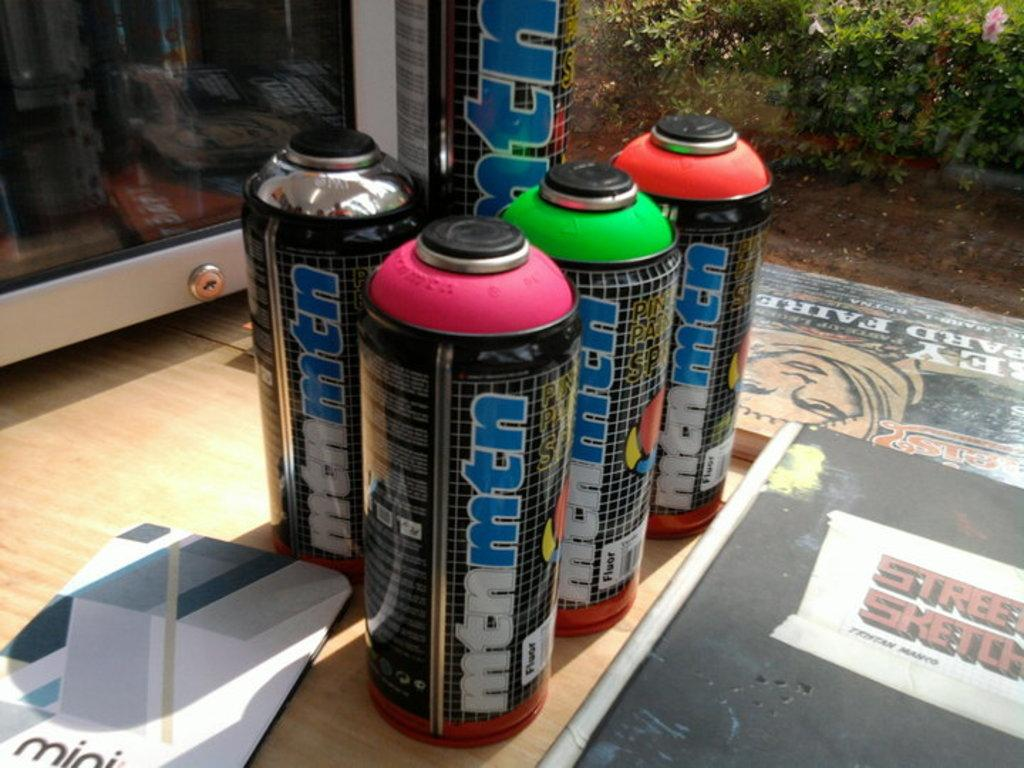<image>
Give a short and clear explanation of the subsequent image. Several cans, labelled mtn mtn, are lined up. 